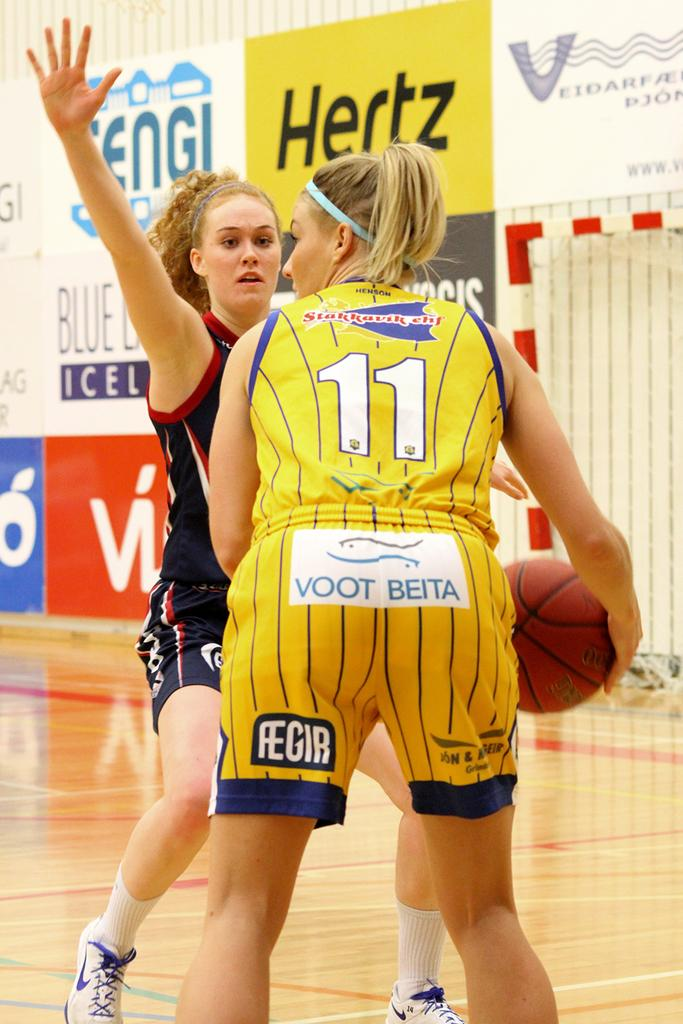<image>
Describe the image concisely. Two female basketball players, one in yellow shorts reading VOOT BEITA, go head to head during a game 